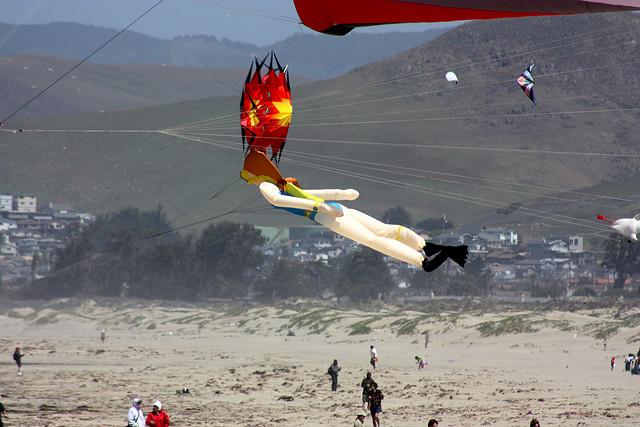What is the weather like in the image? The weather in the image appears to be cool and slightly overcast. There are enough clouds to suggest that the sun may be partially obscured, casting a soft, diffused light over the scene. The presence of jackets on the individuals on the beach indicates that the temperature is likely on the cooler side. Moreover, the clear visibility of the kites' strings and their stable flight patterns suggest a steady breeze, ideal for kite flying. 